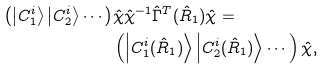Convert formula to latex. <formula><loc_0><loc_0><loc_500><loc_500>\left ( \left | C ^ { i } _ { 1 } \right > \left | C ^ { i } _ { 2 } \right > \cdots \right ) & \hat { \chi } \hat { \chi } ^ { - 1 } \hat { \Gamma } ^ { T } ( \hat { R } _ { 1 } ) \hat { \chi } = \\ & \left ( \left | C ^ { i } _ { 1 } ( \hat { R } _ { 1 } ) \right > \left | C ^ { i } _ { 2 } ( \hat { R } _ { 1 } ) \right > \cdots \right ) \hat { \chi } ,</formula> 